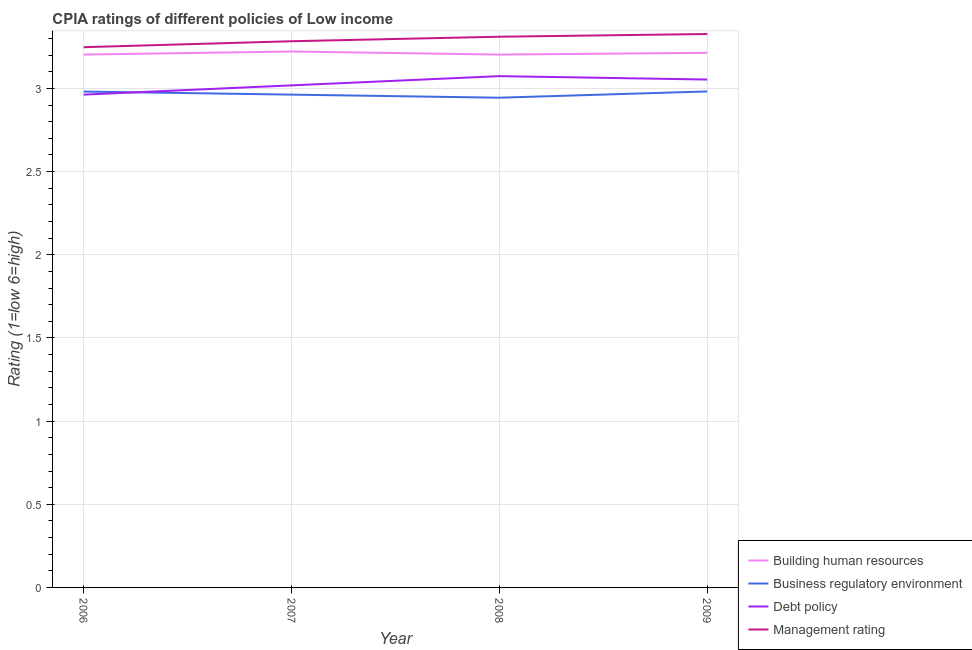How many different coloured lines are there?
Your answer should be compact. 4. What is the cpia rating of building human resources in 2006?
Offer a very short reply. 3.2. Across all years, what is the maximum cpia rating of management?
Keep it short and to the point. 3.33. Across all years, what is the minimum cpia rating of business regulatory environment?
Your response must be concise. 2.94. What is the total cpia rating of debt policy in the graph?
Provide a short and direct response. 12.11. What is the difference between the cpia rating of debt policy in 2006 and the cpia rating of business regulatory environment in 2008?
Keep it short and to the point. 0.02. What is the average cpia rating of debt policy per year?
Your answer should be very brief. 3.03. In the year 2009, what is the difference between the cpia rating of business regulatory environment and cpia rating of debt policy?
Your response must be concise. -0.07. In how many years, is the cpia rating of management greater than 1.4?
Make the answer very short. 4. What is the ratio of the cpia rating of business regulatory environment in 2008 to that in 2009?
Your response must be concise. 0.99. What is the difference between the highest and the second highest cpia rating of business regulatory environment?
Your answer should be compact. 0. What is the difference between the highest and the lowest cpia rating of debt policy?
Offer a very short reply. 0.11. In how many years, is the cpia rating of debt policy greater than the average cpia rating of debt policy taken over all years?
Offer a very short reply. 2. Is the sum of the cpia rating of debt policy in 2006 and 2008 greater than the maximum cpia rating of business regulatory environment across all years?
Offer a terse response. Yes. Is the cpia rating of business regulatory environment strictly less than the cpia rating of management over the years?
Give a very brief answer. Yes. What is the difference between two consecutive major ticks on the Y-axis?
Ensure brevity in your answer.  0.5. What is the title of the graph?
Make the answer very short. CPIA ratings of different policies of Low income. What is the label or title of the X-axis?
Provide a succinct answer. Year. What is the Rating (1=low 6=high) of Building human resources in 2006?
Your answer should be compact. 3.2. What is the Rating (1=low 6=high) in Business regulatory environment in 2006?
Offer a terse response. 2.98. What is the Rating (1=low 6=high) in Debt policy in 2006?
Give a very brief answer. 2.96. What is the Rating (1=low 6=high) of Management rating in 2006?
Make the answer very short. 3.25. What is the Rating (1=low 6=high) in Building human resources in 2007?
Offer a very short reply. 3.22. What is the Rating (1=low 6=high) of Business regulatory environment in 2007?
Offer a terse response. 2.96. What is the Rating (1=low 6=high) of Debt policy in 2007?
Provide a short and direct response. 3.02. What is the Rating (1=low 6=high) in Management rating in 2007?
Offer a terse response. 3.28. What is the Rating (1=low 6=high) of Building human resources in 2008?
Your response must be concise. 3.2. What is the Rating (1=low 6=high) in Business regulatory environment in 2008?
Offer a very short reply. 2.94. What is the Rating (1=low 6=high) in Debt policy in 2008?
Provide a succinct answer. 3.07. What is the Rating (1=low 6=high) of Management rating in 2008?
Your answer should be very brief. 3.31. What is the Rating (1=low 6=high) of Building human resources in 2009?
Make the answer very short. 3.21. What is the Rating (1=low 6=high) of Business regulatory environment in 2009?
Make the answer very short. 2.98. What is the Rating (1=low 6=high) in Debt policy in 2009?
Offer a very short reply. 3.05. What is the Rating (1=low 6=high) of Management rating in 2009?
Give a very brief answer. 3.33. Across all years, what is the maximum Rating (1=low 6=high) in Building human resources?
Your answer should be compact. 3.22. Across all years, what is the maximum Rating (1=low 6=high) of Business regulatory environment?
Make the answer very short. 2.98. Across all years, what is the maximum Rating (1=low 6=high) of Debt policy?
Make the answer very short. 3.07. Across all years, what is the maximum Rating (1=low 6=high) in Management rating?
Provide a succinct answer. 3.33. Across all years, what is the minimum Rating (1=low 6=high) of Building human resources?
Offer a terse response. 3.2. Across all years, what is the minimum Rating (1=low 6=high) of Business regulatory environment?
Your response must be concise. 2.94. Across all years, what is the minimum Rating (1=low 6=high) in Debt policy?
Your answer should be very brief. 2.96. Across all years, what is the minimum Rating (1=low 6=high) of Management rating?
Make the answer very short. 3.25. What is the total Rating (1=low 6=high) in Building human resources in the graph?
Your answer should be compact. 12.84. What is the total Rating (1=low 6=high) of Business regulatory environment in the graph?
Your answer should be very brief. 11.87. What is the total Rating (1=low 6=high) of Debt policy in the graph?
Provide a succinct answer. 12.11. What is the total Rating (1=low 6=high) in Management rating in the graph?
Your response must be concise. 13.17. What is the difference between the Rating (1=low 6=high) in Building human resources in 2006 and that in 2007?
Provide a succinct answer. -0.02. What is the difference between the Rating (1=low 6=high) in Business regulatory environment in 2006 and that in 2007?
Your response must be concise. 0.02. What is the difference between the Rating (1=low 6=high) in Debt policy in 2006 and that in 2007?
Give a very brief answer. -0.06. What is the difference between the Rating (1=low 6=high) of Management rating in 2006 and that in 2007?
Provide a short and direct response. -0.04. What is the difference between the Rating (1=low 6=high) of Building human resources in 2006 and that in 2008?
Keep it short and to the point. 0. What is the difference between the Rating (1=low 6=high) in Business regulatory environment in 2006 and that in 2008?
Your answer should be very brief. 0.04. What is the difference between the Rating (1=low 6=high) of Debt policy in 2006 and that in 2008?
Provide a succinct answer. -0.11. What is the difference between the Rating (1=low 6=high) in Management rating in 2006 and that in 2008?
Ensure brevity in your answer.  -0.06. What is the difference between the Rating (1=low 6=high) of Building human resources in 2006 and that in 2009?
Make the answer very short. -0.01. What is the difference between the Rating (1=low 6=high) in Business regulatory environment in 2006 and that in 2009?
Make the answer very short. -0. What is the difference between the Rating (1=low 6=high) of Debt policy in 2006 and that in 2009?
Ensure brevity in your answer.  -0.09. What is the difference between the Rating (1=low 6=high) in Management rating in 2006 and that in 2009?
Provide a succinct answer. -0.08. What is the difference between the Rating (1=low 6=high) of Building human resources in 2007 and that in 2008?
Offer a terse response. 0.02. What is the difference between the Rating (1=low 6=high) in Business regulatory environment in 2007 and that in 2008?
Make the answer very short. 0.02. What is the difference between the Rating (1=low 6=high) in Debt policy in 2007 and that in 2008?
Provide a succinct answer. -0.06. What is the difference between the Rating (1=low 6=high) in Management rating in 2007 and that in 2008?
Provide a succinct answer. -0.03. What is the difference between the Rating (1=low 6=high) in Building human resources in 2007 and that in 2009?
Provide a succinct answer. 0.01. What is the difference between the Rating (1=low 6=high) in Business regulatory environment in 2007 and that in 2009?
Offer a very short reply. -0.02. What is the difference between the Rating (1=low 6=high) in Debt policy in 2007 and that in 2009?
Keep it short and to the point. -0.04. What is the difference between the Rating (1=low 6=high) in Management rating in 2007 and that in 2009?
Give a very brief answer. -0.04. What is the difference between the Rating (1=low 6=high) in Building human resources in 2008 and that in 2009?
Provide a short and direct response. -0.01. What is the difference between the Rating (1=low 6=high) of Business regulatory environment in 2008 and that in 2009?
Provide a succinct answer. -0.04. What is the difference between the Rating (1=low 6=high) of Debt policy in 2008 and that in 2009?
Provide a short and direct response. 0.02. What is the difference between the Rating (1=low 6=high) of Management rating in 2008 and that in 2009?
Keep it short and to the point. -0.02. What is the difference between the Rating (1=low 6=high) of Building human resources in 2006 and the Rating (1=low 6=high) of Business regulatory environment in 2007?
Provide a succinct answer. 0.24. What is the difference between the Rating (1=low 6=high) of Building human resources in 2006 and the Rating (1=low 6=high) of Debt policy in 2007?
Make the answer very short. 0.19. What is the difference between the Rating (1=low 6=high) in Building human resources in 2006 and the Rating (1=low 6=high) in Management rating in 2007?
Your answer should be very brief. -0.08. What is the difference between the Rating (1=low 6=high) in Business regulatory environment in 2006 and the Rating (1=low 6=high) in Debt policy in 2007?
Offer a very short reply. -0.04. What is the difference between the Rating (1=low 6=high) of Business regulatory environment in 2006 and the Rating (1=low 6=high) of Management rating in 2007?
Give a very brief answer. -0.3. What is the difference between the Rating (1=low 6=high) in Debt policy in 2006 and the Rating (1=low 6=high) in Management rating in 2007?
Provide a succinct answer. -0.32. What is the difference between the Rating (1=low 6=high) of Building human resources in 2006 and the Rating (1=low 6=high) of Business regulatory environment in 2008?
Your answer should be compact. 0.26. What is the difference between the Rating (1=low 6=high) of Building human resources in 2006 and the Rating (1=low 6=high) of Debt policy in 2008?
Your response must be concise. 0.13. What is the difference between the Rating (1=low 6=high) of Building human resources in 2006 and the Rating (1=low 6=high) of Management rating in 2008?
Provide a short and direct response. -0.11. What is the difference between the Rating (1=low 6=high) in Business regulatory environment in 2006 and the Rating (1=low 6=high) in Debt policy in 2008?
Give a very brief answer. -0.09. What is the difference between the Rating (1=low 6=high) in Business regulatory environment in 2006 and the Rating (1=low 6=high) in Management rating in 2008?
Give a very brief answer. -0.33. What is the difference between the Rating (1=low 6=high) of Debt policy in 2006 and the Rating (1=low 6=high) of Management rating in 2008?
Provide a short and direct response. -0.35. What is the difference between the Rating (1=low 6=high) of Building human resources in 2006 and the Rating (1=low 6=high) of Business regulatory environment in 2009?
Your response must be concise. 0.22. What is the difference between the Rating (1=low 6=high) in Building human resources in 2006 and the Rating (1=low 6=high) in Debt policy in 2009?
Ensure brevity in your answer.  0.15. What is the difference between the Rating (1=low 6=high) of Building human resources in 2006 and the Rating (1=low 6=high) of Management rating in 2009?
Provide a short and direct response. -0.12. What is the difference between the Rating (1=low 6=high) of Business regulatory environment in 2006 and the Rating (1=low 6=high) of Debt policy in 2009?
Provide a succinct answer. -0.07. What is the difference between the Rating (1=low 6=high) of Business regulatory environment in 2006 and the Rating (1=low 6=high) of Management rating in 2009?
Your answer should be compact. -0.35. What is the difference between the Rating (1=low 6=high) in Debt policy in 2006 and the Rating (1=low 6=high) in Management rating in 2009?
Offer a very short reply. -0.36. What is the difference between the Rating (1=low 6=high) in Building human resources in 2007 and the Rating (1=low 6=high) in Business regulatory environment in 2008?
Offer a terse response. 0.28. What is the difference between the Rating (1=low 6=high) of Building human resources in 2007 and the Rating (1=low 6=high) of Debt policy in 2008?
Offer a terse response. 0.15. What is the difference between the Rating (1=low 6=high) of Building human resources in 2007 and the Rating (1=low 6=high) of Management rating in 2008?
Your response must be concise. -0.09. What is the difference between the Rating (1=low 6=high) of Business regulatory environment in 2007 and the Rating (1=low 6=high) of Debt policy in 2008?
Give a very brief answer. -0.11. What is the difference between the Rating (1=low 6=high) of Business regulatory environment in 2007 and the Rating (1=low 6=high) of Management rating in 2008?
Keep it short and to the point. -0.35. What is the difference between the Rating (1=low 6=high) in Debt policy in 2007 and the Rating (1=low 6=high) in Management rating in 2008?
Make the answer very short. -0.29. What is the difference between the Rating (1=low 6=high) of Building human resources in 2007 and the Rating (1=low 6=high) of Business regulatory environment in 2009?
Make the answer very short. 0.24. What is the difference between the Rating (1=low 6=high) of Building human resources in 2007 and the Rating (1=low 6=high) of Debt policy in 2009?
Offer a very short reply. 0.17. What is the difference between the Rating (1=low 6=high) in Building human resources in 2007 and the Rating (1=low 6=high) in Management rating in 2009?
Ensure brevity in your answer.  -0.11. What is the difference between the Rating (1=low 6=high) of Business regulatory environment in 2007 and the Rating (1=low 6=high) of Debt policy in 2009?
Make the answer very short. -0.09. What is the difference between the Rating (1=low 6=high) in Business regulatory environment in 2007 and the Rating (1=low 6=high) in Management rating in 2009?
Give a very brief answer. -0.36. What is the difference between the Rating (1=low 6=high) in Debt policy in 2007 and the Rating (1=low 6=high) in Management rating in 2009?
Your response must be concise. -0.31. What is the difference between the Rating (1=low 6=high) of Building human resources in 2008 and the Rating (1=low 6=high) of Business regulatory environment in 2009?
Your response must be concise. 0.22. What is the difference between the Rating (1=low 6=high) in Building human resources in 2008 and the Rating (1=low 6=high) in Debt policy in 2009?
Your answer should be very brief. 0.15. What is the difference between the Rating (1=low 6=high) of Building human resources in 2008 and the Rating (1=low 6=high) of Management rating in 2009?
Offer a terse response. -0.12. What is the difference between the Rating (1=low 6=high) in Business regulatory environment in 2008 and the Rating (1=low 6=high) in Debt policy in 2009?
Offer a very short reply. -0.11. What is the difference between the Rating (1=low 6=high) in Business regulatory environment in 2008 and the Rating (1=low 6=high) in Management rating in 2009?
Provide a short and direct response. -0.38. What is the difference between the Rating (1=low 6=high) in Debt policy in 2008 and the Rating (1=low 6=high) in Management rating in 2009?
Your answer should be compact. -0.25. What is the average Rating (1=low 6=high) in Building human resources per year?
Offer a very short reply. 3.21. What is the average Rating (1=low 6=high) in Business regulatory environment per year?
Your answer should be compact. 2.97. What is the average Rating (1=low 6=high) in Debt policy per year?
Make the answer very short. 3.03. What is the average Rating (1=low 6=high) in Management rating per year?
Keep it short and to the point. 3.29. In the year 2006, what is the difference between the Rating (1=low 6=high) in Building human resources and Rating (1=low 6=high) in Business regulatory environment?
Provide a short and direct response. 0.22. In the year 2006, what is the difference between the Rating (1=low 6=high) of Building human resources and Rating (1=low 6=high) of Debt policy?
Your answer should be very brief. 0.24. In the year 2006, what is the difference between the Rating (1=low 6=high) in Building human resources and Rating (1=low 6=high) in Management rating?
Make the answer very short. -0.04. In the year 2006, what is the difference between the Rating (1=low 6=high) in Business regulatory environment and Rating (1=low 6=high) in Debt policy?
Offer a very short reply. 0.02. In the year 2006, what is the difference between the Rating (1=low 6=high) in Business regulatory environment and Rating (1=low 6=high) in Management rating?
Give a very brief answer. -0.27. In the year 2006, what is the difference between the Rating (1=low 6=high) in Debt policy and Rating (1=low 6=high) in Management rating?
Your response must be concise. -0.29. In the year 2007, what is the difference between the Rating (1=low 6=high) in Building human resources and Rating (1=low 6=high) in Business regulatory environment?
Provide a short and direct response. 0.26. In the year 2007, what is the difference between the Rating (1=low 6=high) of Building human resources and Rating (1=low 6=high) of Debt policy?
Your response must be concise. 0.2. In the year 2007, what is the difference between the Rating (1=low 6=high) in Building human resources and Rating (1=low 6=high) in Management rating?
Provide a succinct answer. -0.06. In the year 2007, what is the difference between the Rating (1=low 6=high) of Business regulatory environment and Rating (1=low 6=high) of Debt policy?
Give a very brief answer. -0.06. In the year 2007, what is the difference between the Rating (1=low 6=high) of Business regulatory environment and Rating (1=low 6=high) of Management rating?
Your answer should be very brief. -0.32. In the year 2007, what is the difference between the Rating (1=low 6=high) of Debt policy and Rating (1=low 6=high) of Management rating?
Offer a terse response. -0.27. In the year 2008, what is the difference between the Rating (1=low 6=high) in Building human resources and Rating (1=low 6=high) in Business regulatory environment?
Give a very brief answer. 0.26. In the year 2008, what is the difference between the Rating (1=low 6=high) of Building human resources and Rating (1=low 6=high) of Debt policy?
Your response must be concise. 0.13. In the year 2008, what is the difference between the Rating (1=low 6=high) of Building human resources and Rating (1=low 6=high) of Management rating?
Offer a very short reply. -0.11. In the year 2008, what is the difference between the Rating (1=low 6=high) in Business regulatory environment and Rating (1=low 6=high) in Debt policy?
Your answer should be very brief. -0.13. In the year 2008, what is the difference between the Rating (1=low 6=high) of Business regulatory environment and Rating (1=low 6=high) of Management rating?
Keep it short and to the point. -0.37. In the year 2008, what is the difference between the Rating (1=low 6=high) of Debt policy and Rating (1=low 6=high) of Management rating?
Your response must be concise. -0.24. In the year 2009, what is the difference between the Rating (1=low 6=high) of Building human resources and Rating (1=low 6=high) of Business regulatory environment?
Make the answer very short. 0.23. In the year 2009, what is the difference between the Rating (1=low 6=high) in Building human resources and Rating (1=low 6=high) in Debt policy?
Your answer should be compact. 0.16. In the year 2009, what is the difference between the Rating (1=low 6=high) in Building human resources and Rating (1=low 6=high) in Management rating?
Offer a very short reply. -0.11. In the year 2009, what is the difference between the Rating (1=low 6=high) of Business regulatory environment and Rating (1=low 6=high) of Debt policy?
Offer a terse response. -0.07. In the year 2009, what is the difference between the Rating (1=low 6=high) of Business regulatory environment and Rating (1=low 6=high) of Management rating?
Ensure brevity in your answer.  -0.35. In the year 2009, what is the difference between the Rating (1=low 6=high) in Debt policy and Rating (1=low 6=high) in Management rating?
Offer a very short reply. -0.27. What is the ratio of the Rating (1=low 6=high) of Building human resources in 2006 to that in 2007?
Offer a very short reply. 0.99. What is the ratio of the Rating (1=low 6=high) of Business regulatory environment in 2006 to that in 2007?
Provide a succinct answer. 1.01. What is the ratio of the Rating (1=low 6=high) of Debt policy in 2006 to that in 2007?
Keep it short and to the point. 0.98. What is the ratio of the Rating (1=low 6=high) in Business regulatory environment in 2006 to that in 2008?
Provide a succinct answer. 1.01. What is the ratio of the Rating (1=low 6=high) in Debt policy in 2006 to that in 2008?
Your response must be concise. 0.96. What is the ratio of the Rating (1=low 6=high) of Management rating in 2006 to that in 2008?
Ensure brevity in your answer.  0.98. What is the ratio of the Rating (1=low 6=high) of Building human resources in 2006 to that in 2009?
Provide a short and direct response. 1. What is the ratio of the Rating (1=low 6=high) of Business regulatory environment in 2006 to that in 2009?
Your response must be concise. 1. What is the ratio of the Rating (1=low 6=high) of Debt policy in 2006 to that in 2009?
Offer a terse response. 0.97. What is the ratio of the Rating (1=low 6=high) of Management rating in 2006 to that in 2009?
Offer a terse response. 0.98. What is the ratio of the Rating (1=low 6=high) of Debt policy in 2007 to that in 2008?
Your answer should be compact. 0.98. What is the ratio of the Rating (1=low 6=high) in Building human resources in 2007 to that in 2009?
Provide a short and direct response. 1. What is the ratio of the Rating (1=low 6=high) in Management rating in 2007 to that in 2009?
Give a very brief answer. 0.99. What is the ratio of the Rating (1=low 6=high) of Business regulatory environment in 2008 to that in 2009?
Provide a succinct answer. 0.99. What is the ratio of the Rating (1=low 6=high) of Debt policy in 2008 to that in 2009?
Give a very brief answer. 1.01. What is the difference between the highest and the second highest Rating (1=low 6=high) in Building human resources?
Offer a terse response. 0.01. What is the difference between the highest and the second highest Rating (1=low 6=high) in Business regulatory environment?
Provide a succinct answer. 0. What is the difference between the highest and the second highest Rating (1=low 6=high) in Debt policy?
Provide a short and direct response. 0.02. What is the difference between the highest and the second highest Rating (1=low 6=high) of Management rating?
Offer a very short reply. 0.02. What is the difference between the highest and the lowest Rating (1=low 6=high) of Building human resources?
Your answer should be compact. 0.02. What is the difference between the highest and the lowest Rating (1=low 6=high) of Business regulatory environment?
Offer a terse response. 0.04. What is the difference between the highest and the lowest Rating (1=low 6=high) in Management rating?
Provide a succinct answer. 0.08. 